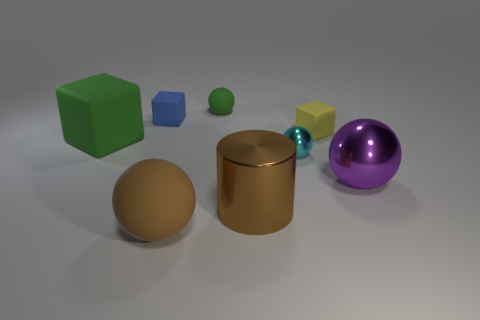Subtract all green spheres. How many spheres are left? 3 Add 1 large green objects. How many objects exist? 9 Subtract all green spheres. How many spheres are left? 3 Subtract all blocks. How many objects are left? 5 Subtract 3 balls. How many balls are left? 1 Add 7 brown objects. How many brown objects exist? 9 Subtract 0 purple cubes. How many objects are left? 8 Subtract all red cylinders. Subtract all red spheres. How many cylinders are left? 1 Subtract all yellow cylinders. How many green cubes are left? 1 Subtract all rubber balls. Subtract all large red rubber balls. How many objects are left? 6 